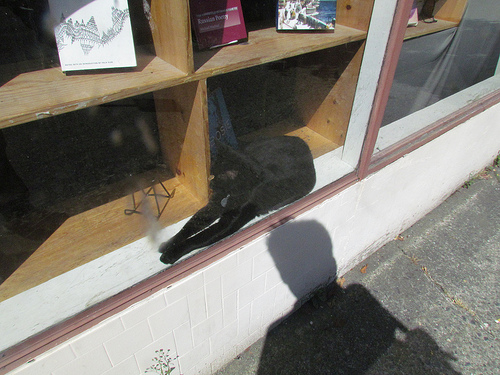<image>
Can you confirm if the cat is in the window? Yes. The cat is contained within or inside the window, showing a containment relationship. 